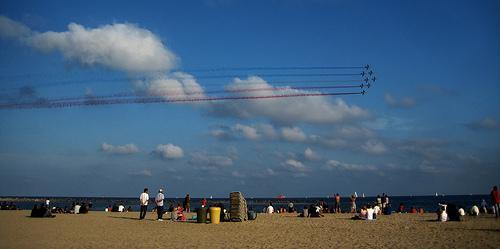How many beaches are pictured?
Give a very brief answer. 1. 